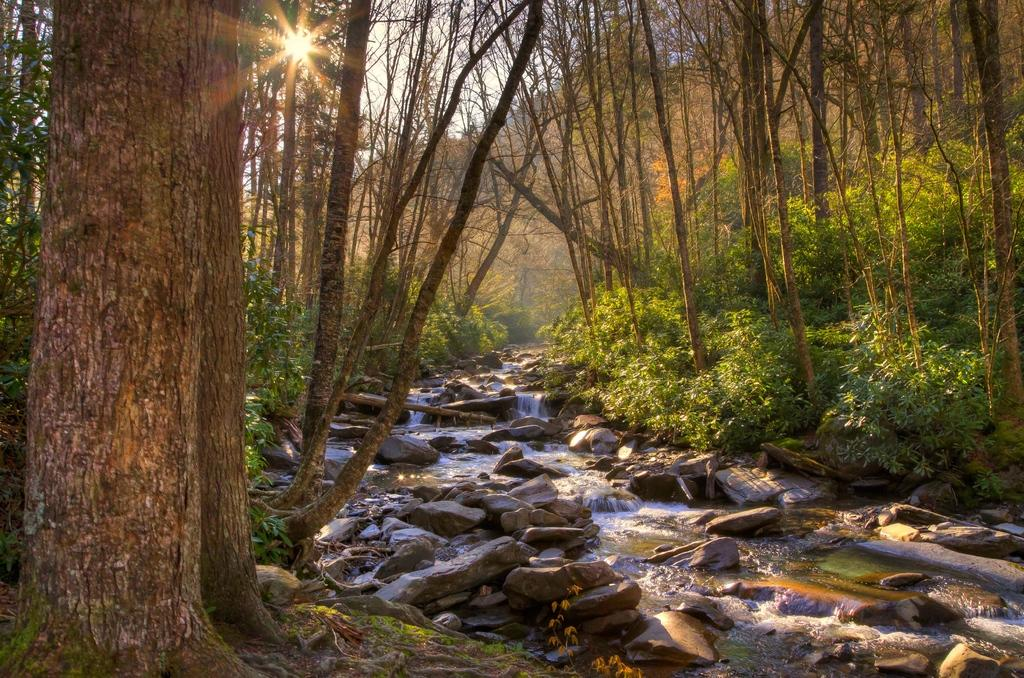What type of vegetation can be seen in the image? There are trees in the image. What is happening in the middle of the image? Water is flowing in the middle of the image. How many oranges are hanging from the trees in the image? There are no oranges present in the image; it features trees and flowing water. Are the friends in the image having trouble with the water flow? There are no friends or any indication of trouble in the image. 